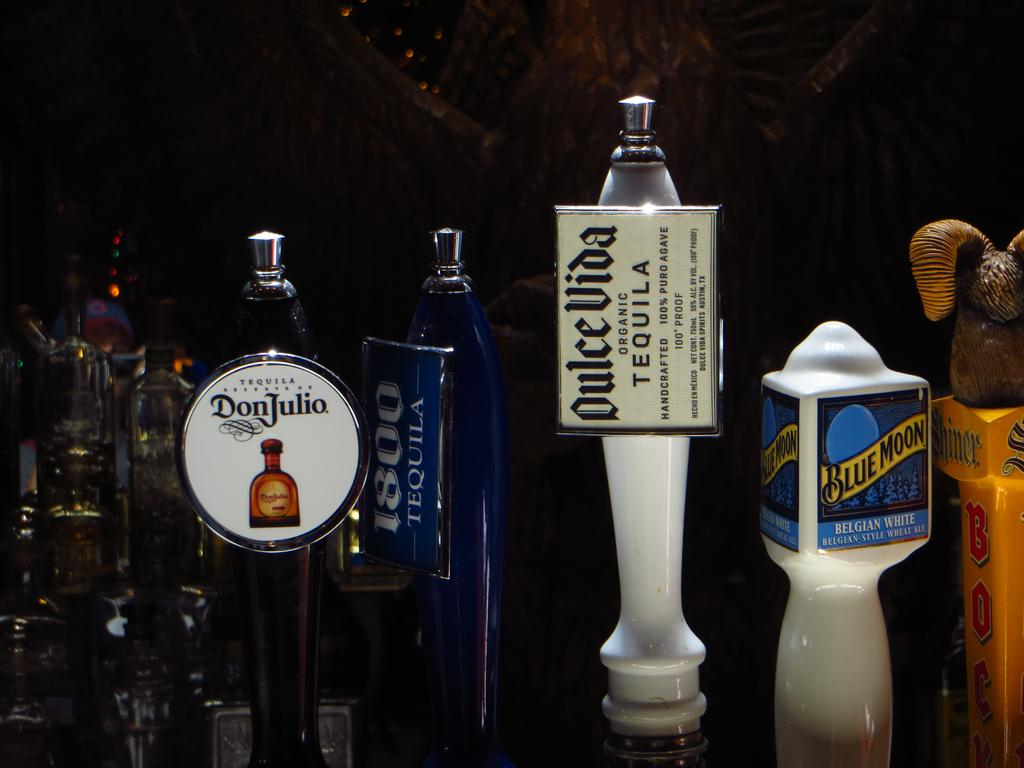<image>
Render a clear and concise summary of the photo. Four beer pumps are seen close up including Blue Moon, DonJulio, 1800 Tequila and others. 